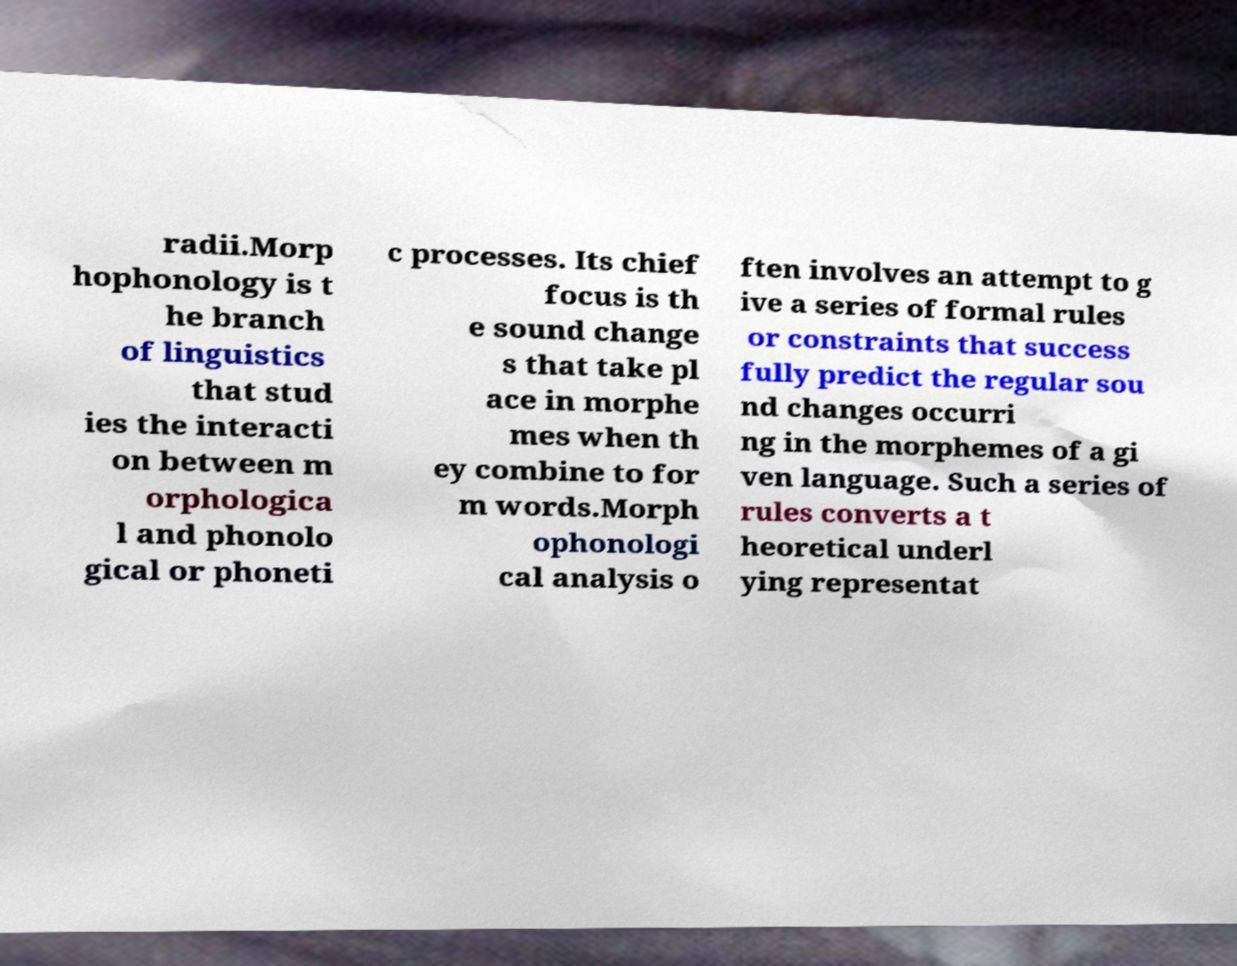There's text embedded in this image that I need extracted. Can you transcribe it verbatim? radii.Morp hophonology is t he branch of linguistics that stud ies the interacti on between m orphologica l and phonolo gical or phoneti c processes. Its chief focus is th e sound change s that take pl ace in morphe mes when th ey combine to for m words.Morph ophonologi cal analysis o ften involves an attempt to g ive a series of formal rules or constraints that success fully predict the regular sou nd changes occurri ng in the morphemes of a gi ven language. Such a series of rules converts a t heoretical underl ying representat 